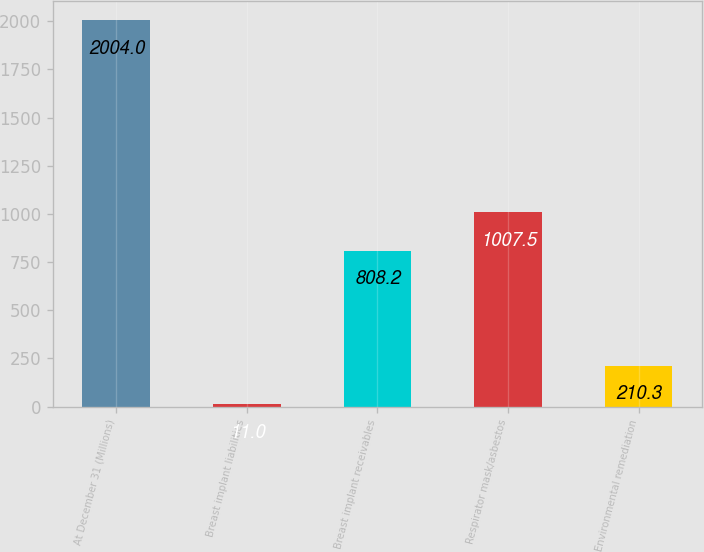Convert chart to OTSL. <chart><loc_0><loc_0><loc_500><loc_500><bar_chart><fcel>At December 31 (Millions)<fcel>Breast implant liabilities<fcel>Breast implant receivables<fcel>Respirator mask/asbestos<fcel>Environmental remediation<nl><fcel>2004<fcel>11<fcel>808.2<fcel>1007.5<fcel>210.3<nl></chart> 